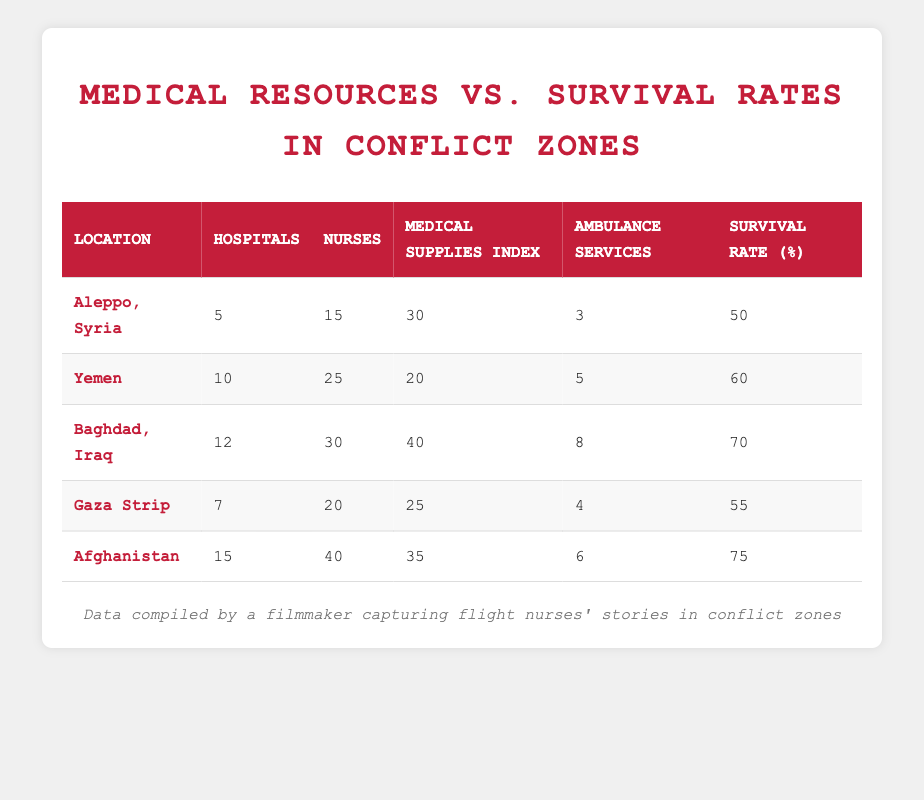What is the survival rate for Baghdad, Iraq? By checking the table, we find that the survival rate listed next to Baghdad, Iraq is 70 percent.
Answer: 70 How many nurses are available in the Gaza Strip? The table indicates that there are 20 nurses available in the Gaza Strip.
Answer: 20 What is the medical supplies index for Aleppo, Syria? The table shows that the medical supplies index for Aleppo, Syria is 30.
Answer: 30 Is the number of hospitals in Yemen greater than in Aleppo, Syria? Comparing the values, Yemen has 10 hospitals while Aleppo has 5, so the number of hospitals in Yemen is indeed greater.
Answer: Yes What is the total number of hospitals across all listed locations? To find the total, we sum the number of hospitals: 5 (Aleppo) + 10 (Yemen) + 12 (Baghdad) + 7 (Gaza) + 15 (Afghanistan) = 49 hospitals in total.
Answer: 49 Which location has the highest number of ambulance services? By examining the ambulance services for each location, we see that Baghdad, Iraq has the highest number with 8 services.
Answer: Baghdad, Iraq Calculate the average survival rate of these locations. To find the average survival rate, we add all survival rates: 50 (Aleppo) + 60 (Yemen) + 70 (Baghdad) + 55 (Gaza) + 75 (Afghanistan) = 310, and then divide by the number of locations (5), giving us an average of 62 percent.
Answer: 62 Do more ambulance services correlate with higher survival rates? Analyzing the data shows that locations with a higher number of ambulance services (like Baghdad with 8 and survival rate 70) do correlate with higher survival rates, while lower ambulance services (like Aleppo with 3 and survival rate 50) correlate with lower survival rates, indicating a potential relationship.
Answer: Yes What is the difference in survival rates between Afghanistan and Gaza Strip? Afghanistan has a survival rate of 75 and Gaza Strip has 55, so the difference is 75 - 55 = 20 percent.
Answer: 20 